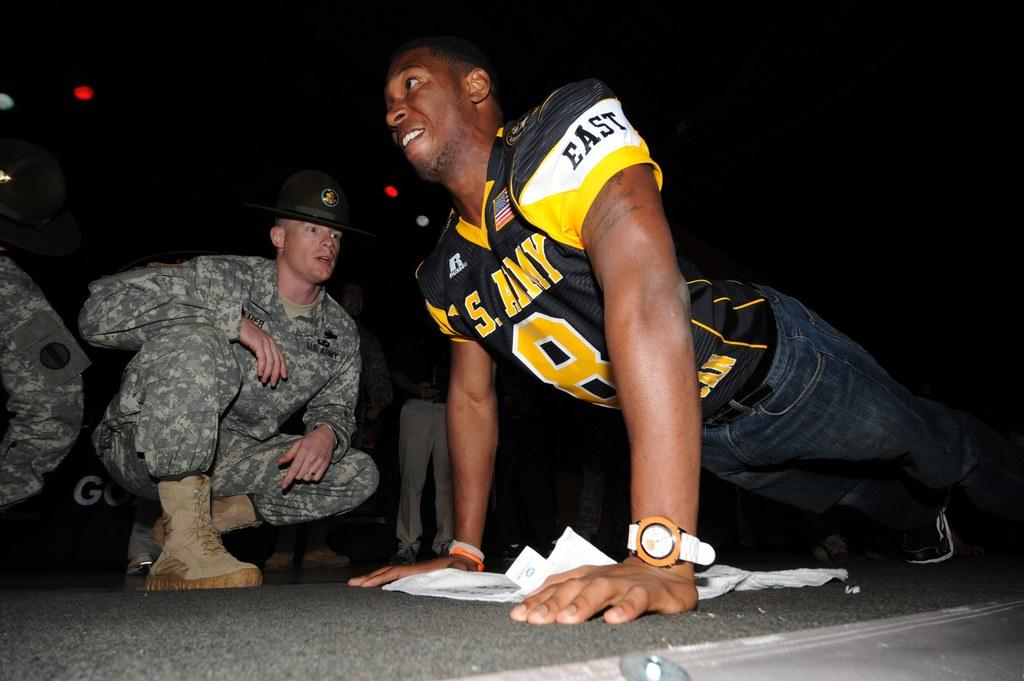<image>
Give a short and clear explanation of the subsequent image. a person with an East jersey doing a push up 